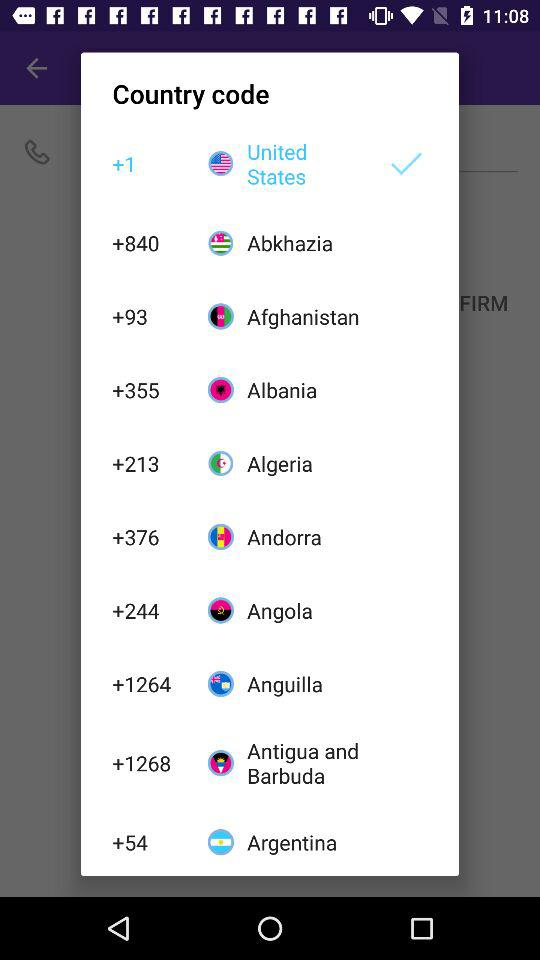What is the country code of the United States? The country code of the United States is +1. 